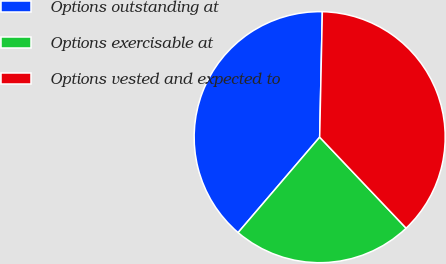Convert chart. <chart><loc_0><loc_0><loc_500><loc_500><pie_chart><fcel>Options outstanding at<fcel>Options exercisable at<fcel>Options vested and expected to<nl><fcel>39.08%<fcel>23.35%<fcel>37.57%<nl></chart> 